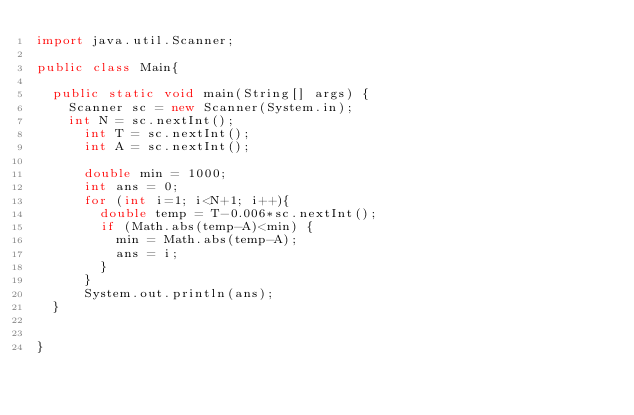Convert code to text. <code><loc_0><loc_0><loc_500><loc_500><_Java_>import java.util.Scanner;

public class Main{

	public static void main(String[] args) {
		Scanner sc = new Scanner(System.in);
		int N = sc.nextInt();
	    int T = sc.nextInt();
	    int A = sc.nextInt();

	    double min = 1000;
	    int ans = 0;
	    for (int i=1; i<N+1; i++){
	    	double temp = T-0.006*sc.nextInt();
	    	if (Math.abs(temp-A)<min) {
	    		min = Math.abs(temp-A);
	    		ans = i;
	    	}
	    }
	    System.out.println(ans);
	}
	

}</code> 